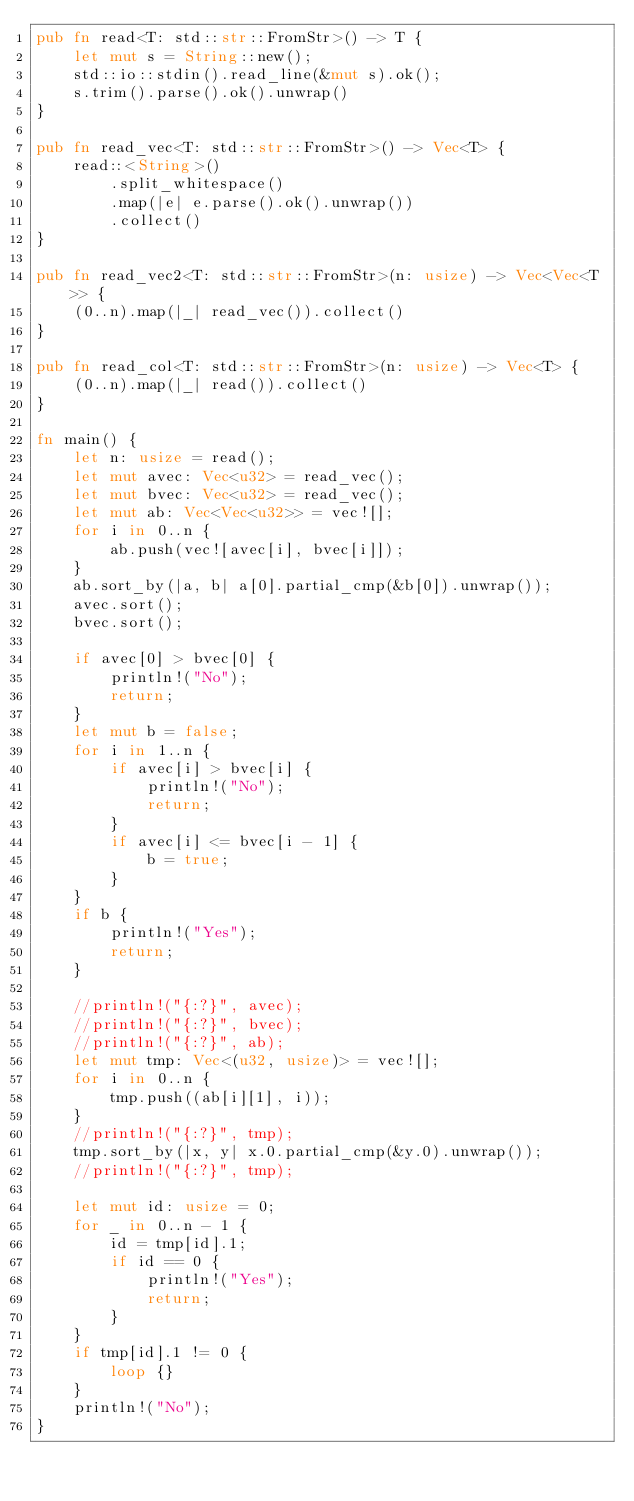Convert code to text. <code><loc_0><loc_0><loc_500><loc_500><_Rust_>pub fn read<T: std::str::FromStr>() -> T {
    let mut s = String::new();
    std::io::stdin().read_line(&mut s).ok();
    s.trim().parse().ok().unwrap()
}

pub fn read_vec<T: std::str::FromStr>() -> Vec<T> {
    read::<String>()
        .split_whitespace()
        .map(|e| e.parse().ok().unwrap())
        .collect()
}

pub fn read_vec2<T: std::str::FromStr>(n: usize) -> Vec<Vec<T>> {
    (0..n).map(|_| read_vec()).collect()
}

pub fn read_col<T: std::str::FromStr>(n: usize) -> Vec<T> {
    (0..n).map(|_| read()).collect()
}

fn main() {
    let n: usize = read();
    let mut avec: Vec<u32> = read_vec();
    let mut bvec: Vec<u32> = read_vec();
    let mut ab: Vec<Vec<u32>> = vec![];
    for i in 0..n {
        ab.push(vec![avec[i], bvec[i]]);
    }
    ab.sort_by(|a, b| a[0].partial_cmp(&b[0]).unwrap());
    avec.sort();
    bvec.sort();

    if avec[0] > bvec[0] {
        println!("No");
        return;
    }
    let mut b = false;
    for i in 1..n {
        if avec[i] > bvec[i] {
            println!("No");
            return;
        }
        if avec[i] <= bvec[i - 1] {
            b = true;
        }
    }
    if b {
        println!("Yes");
        return;
    }

    //println!("{:?}", avec);
    //println!("{:?}", bvec);
    //println!("{:?}", ab);
    let mut tmp: Vec<(u32, usize)> = vec![];
    for i in 0..n {
        tmp.push((ab[i][1], i));
    }
    //println!("{:?}", tmp);
    tmp.sort_by(|x, y| x.0.partial_cmp(&y.0).unwrap());
    //println!("{:?}", tmp);

    let mut id: usize = 0;
    for _ in 0..n - 1 {
        id = tmp[id].1;
        if id == 0 {
            println!("Yes");
            return;
        }
    }
    if tmp[id].1 != 0 {
        loop {}
    }
    println!("No");
}
</code> 